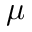<formula> <loc_0><loc_0><loc_500><loc_500>\mu</formula> 